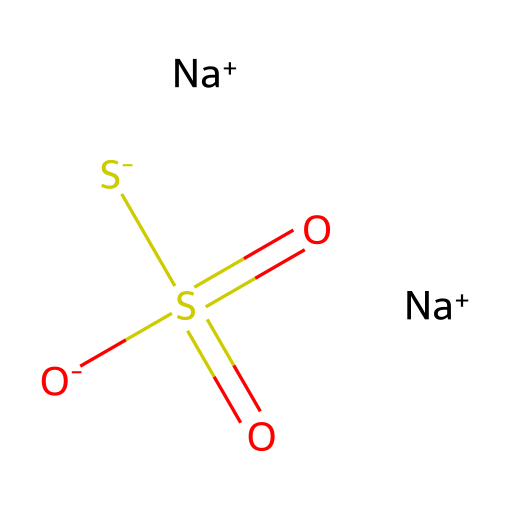How many sodium atoms are present in this chemical? The SMILES representation shows two instances of [Na+], indicating there are two sodium atoms.
Answer: two What is the oxidation state of sulfur in this chemical? The sulfur atom in this chemical is bonded to four oxygens, with two being double bonds (S=O), and the negative charges from two sulfurs imply that sulfur is in the +6 oxidation state.
Answer: +6 Which part of this chemical indicates its acid-base properties? The presence of the sulfate groups, specifically with the sulfonic acid-like structure with negatively charged oxygen atoms, signifies its ability to act as an acid.
Answer: sulfate What is the overall charge of this chemical? Counting the charges: there are two sodium ions (+2) and one sulfide ion (-1), yielding a total charge of +1.
Answer: +1 How many oxygen atoms are present in this chemical? The chemical structure contains three oxygen atoms in the sulfates (two double-bonded and one single-bonded to sulfur), thus making a total of four oxygen atoms.
Answer: four What chemical family does this substance belong to? The presence of sodium and sulfate groups indicates that this chemical is a salt, specifically a sodium sulfate salt.
Answer: salt 